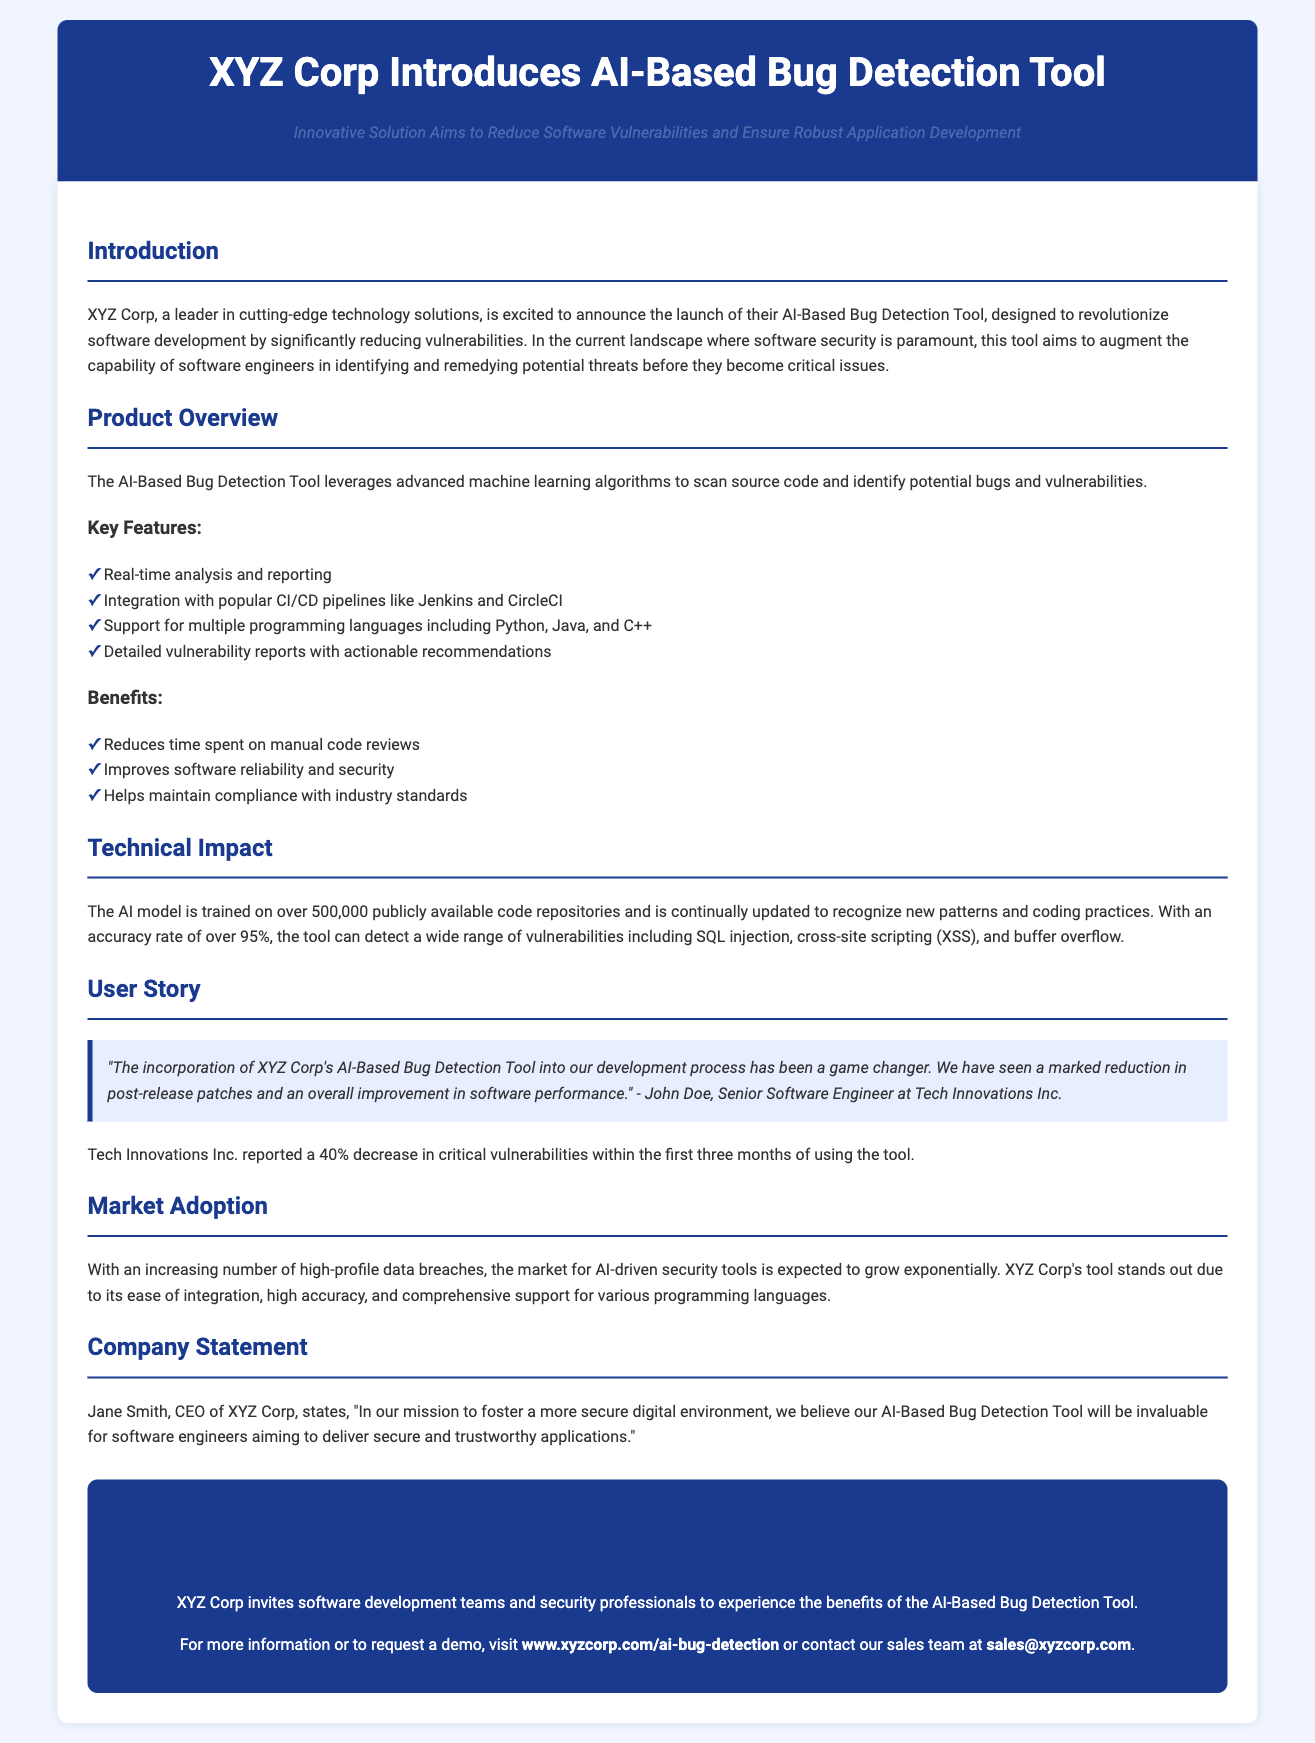What is the name of the tool introduced by XYZ Corp? The name of the tool is mentioned in the title of the press release.
Answer: AI-Based Bug Detection Tool What percentage of reduction in critical vulnerabilities was reported by Tech Innovations Inc.? This information can be found in the user story section of the document.
Answer: 40% Who is the CEO of XYZ Corp? The CEO's name is provided in the company statement section.
Answer: Jane Smith What programming languages does the tool support? The supported programming languages are listed in the product overview section.
Answer: Python, Java, C++ What is the accuracy rate of the AI model used in the tool? This information is stated in the technical impact section of the document.
Answer: Over 95% What are the two popular CI/CD pipelines mentioned for integration? This information can be found in the key features section of the product overview.
Answer: Jenkins and CircleCI What is one of the key benefits of the AI-Based Bug Detection Tool? This information can be found under the benefits section.
Answer: Improves software reliability and security What type of document is this? The structure and content indicate what type of document this is.
Answer: Press release What is the background color of the body in the document? The document specifies aesthetic styles which include the body background color.
Answer: #f0f5ff 